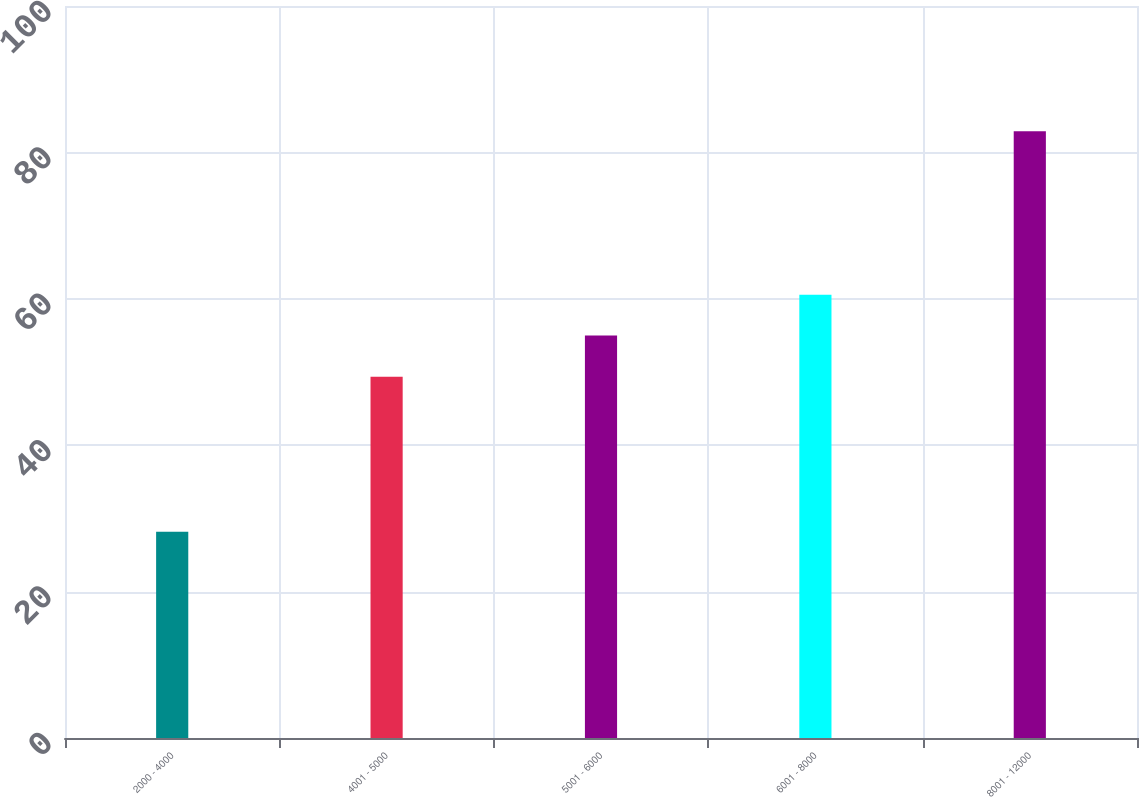Convert chart to OTSL. <chart><loc_0><loc_0><loc_500><loc_500><bar_chart><fcel>2000 - 4000<fcel>4001 - 5000<fcel>5001 - 6000<fcel>6001 - 8000<fcel>8001 - 12000<nl><fcel>28.16<fcel>49.36<fcel>54.98<fcel>60.55<fcel>82.89<nl></chart> 